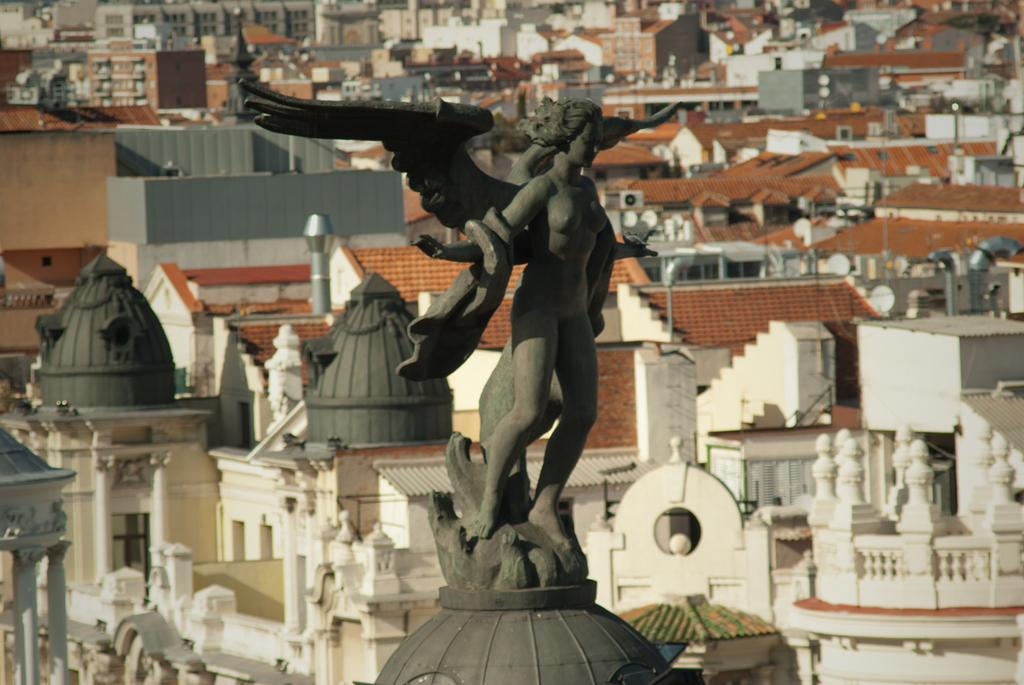What type of structures can be seen in the image? There are statues and buildings in the image. What else is present in the image besides structures? There are poles in the image. Can you see any matches being lit in the image? There are no matches present in the image. Are there any creatures with fangs visible in the image? There are no creatures or fangs present in the image. 